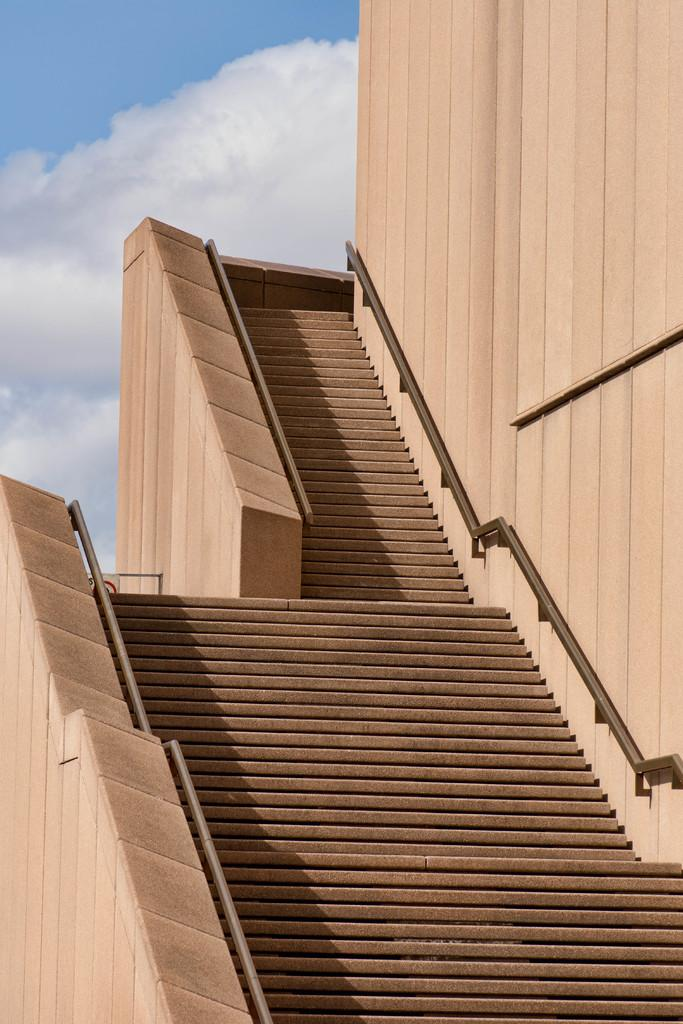What type of structure is present in the image? There is a wall in the image. What architectural feature is also visible in the image? There are stairs in the image. What can be seen in the background of the image? The sky is visible in the background of the image. What type of machine is being used to clean the dirt in the image? There is no machine or dirt present in the image. Is there a whip visible in the image? No, there is no whip present in the image. 